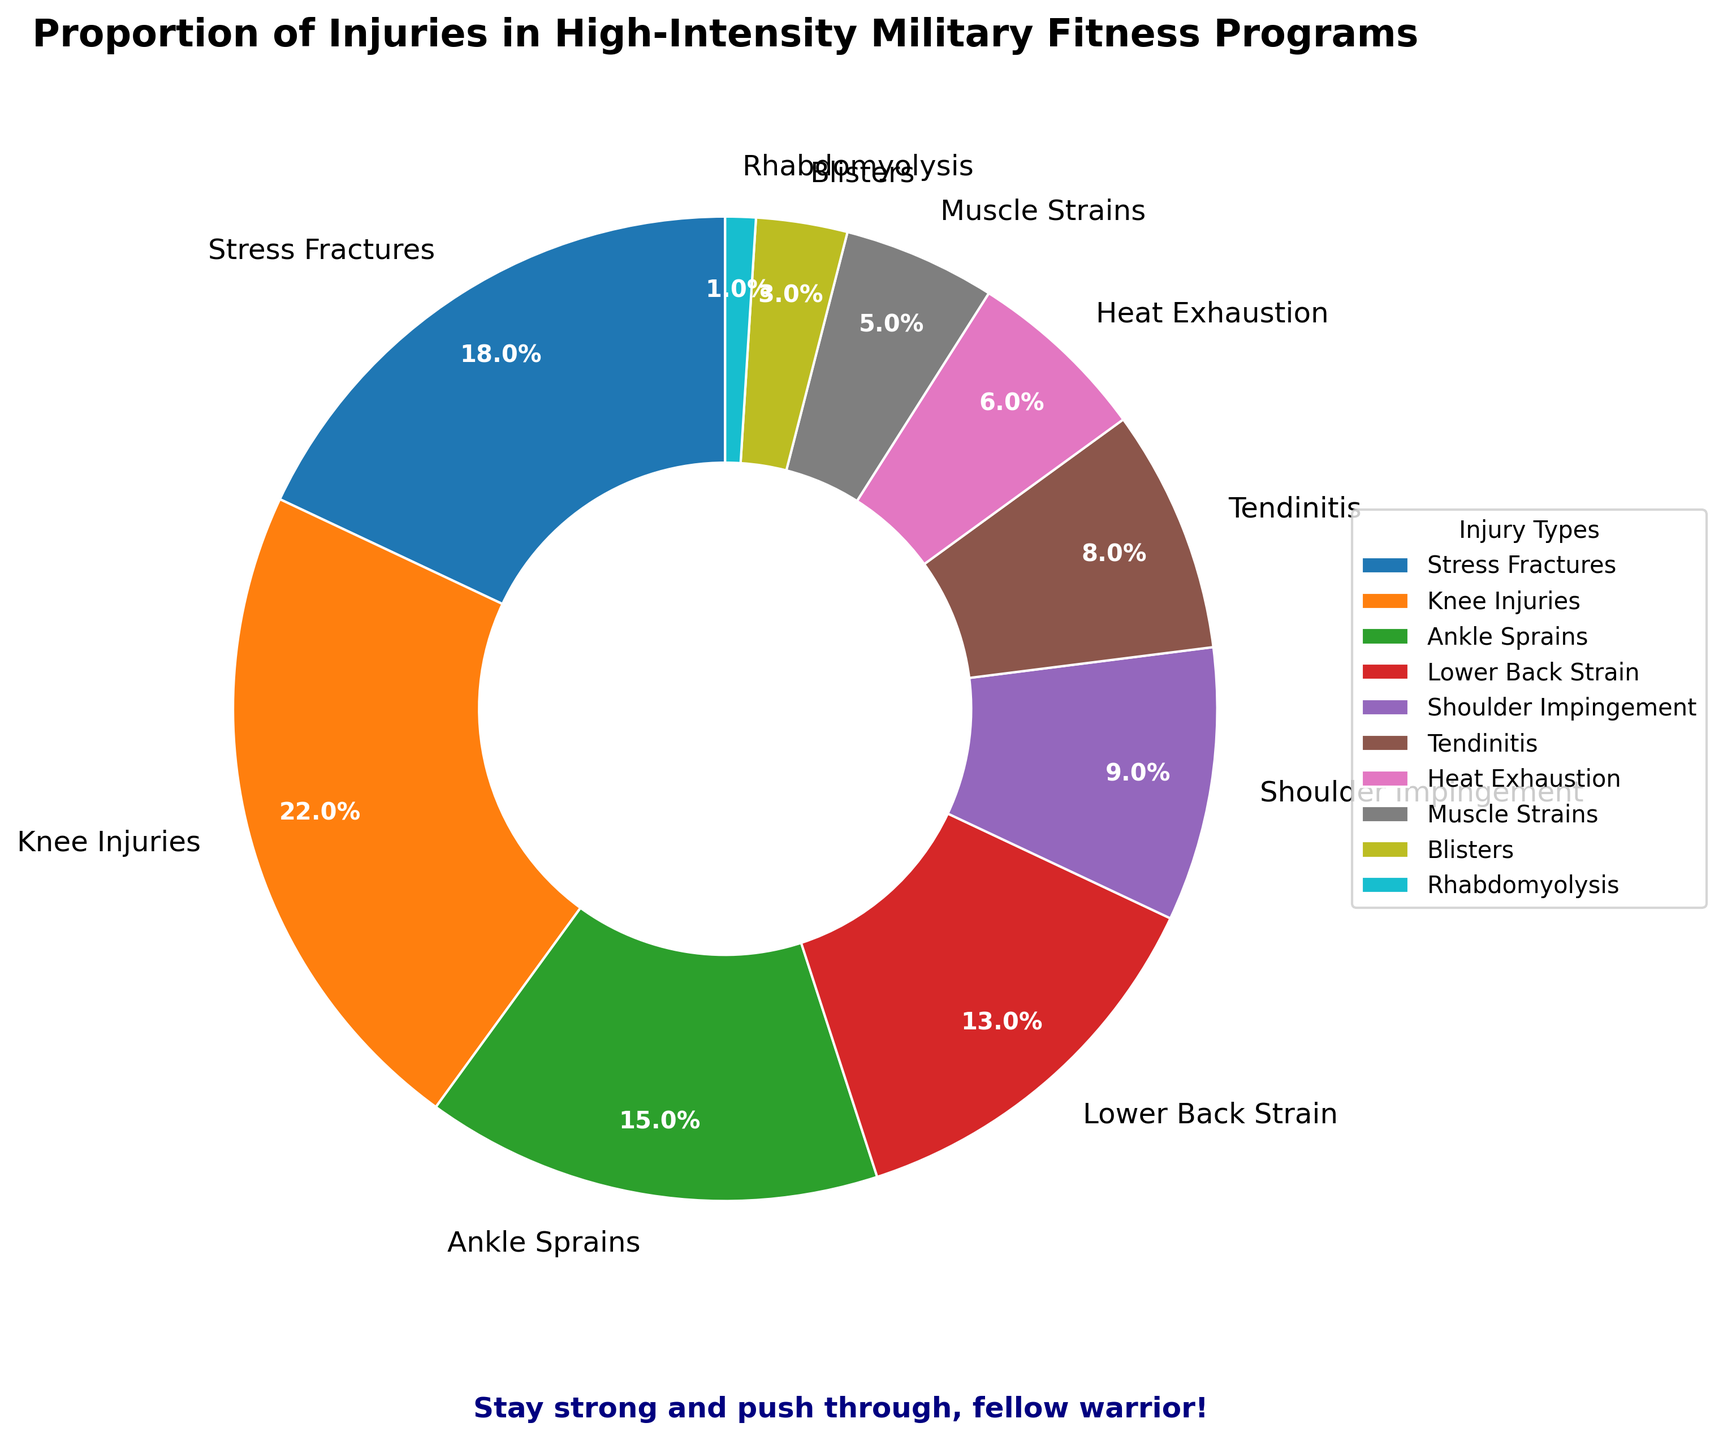Which injury type is represented by the largest section of the pie chart? The largest section of the pie chart represents the injury type with the highest percentage. The label on this section indicates "Knee Injuries" at 22%.
Answer: Knee Injuries How much larger is the proportion of Stress Fractures compared to Muscle Strains? Stress Fractures account for 18% while Muscle Strains account for 5%. The difference between these percentages is 18% - 5% = 13%.
Answer: 13% What are the three most common injury types and their percentages? By examining the size of the sections and their labels, the three largest sections represent Knee Injuries (22%), Stress Fractures (18%), and Ankle Sprains (15%).
Answer: Knee Injuries (22%), Stress Fractures (18%), Ankle Sprains (15%) Which injury types together make up less than 10% each, and collectively sum to more than 20%? Injury types with less than 10% individually are Shoulder Impingement (9%), Tendinitis (8%), Heat Exhaustion (6%), Muscle Strains (5%), Blisters (3%), and Rhabdomyolysis (1%). Their collective sum is 9% + 8% + 6% + 5% + 3% + 1% = 32%.
Answer: Shoulder Impingement, Tendinitis, Heat Exhaustion, Muscle Strains, Blisters, Rhabdomyolysis (32%) What is the total proportion of injuries related to the lower body (Stress Fractures, Knee Injuries, Ankle Sprains)? Adding the percentages for Stress Fractures (18%), Knee Injuries (22%), and Ankle Sprains (15%) gives 18% + 22% + 15% = 55%.
Answer: 55% Is the proportion of Lower Back Strain greater than that of Shoulder Impingement? Lower Back Strain accounts for 13% while Shoulder Impingement accounts for 9%. Since 13% is greater than 9%, the answer is yes.
Answer: Yes What is the percentage difference between the most common and least common injury types? The most common injury type is Knee Injuries at 22%, and the least common is Rhabdomyolysis at 1%. The percentage difference is 22% - 1% = 21%.
Answer: 21% How many injury types have a representation of less than 10% each? By counting the sections labeled with percentages less than 10%, we find Shoulder Impingement (9%), Tendinitis (8%), Heat Exhaustion (6%), Muscle Strains (5%), Blisters (3%), and Rhabdomyolysis (1%). There are 6 such injury types.
Answer: 6 If the pie chart represents 100 individual cases, how many cases are related to Tendinitis? Tendinitis accounts for 8% of the pie chart. If the total number of cases is 100, then the number of Tendinitis cases is 8% of 100, which is 0.08 * 100 = 8 cases.
Answer: 8 What injury types together make up exactly 50% of the injuries? The top two injury types, Knee Injuries (22%) and Stress Fractures (18%), add up to 22% + 18% = 40%, not reaching 50%. Adding the next one, Ankle Sprains (15%), totals 55%, exceeding 50%. Therefore, two specific injury types summing to exactly 50% are not present, but Knee Injuries and Stress Fractures together make up the majority without hitting exactly 50%.
Answer: Not available 